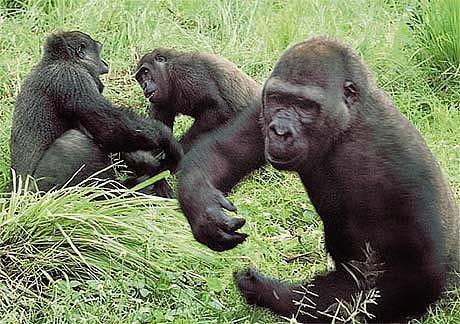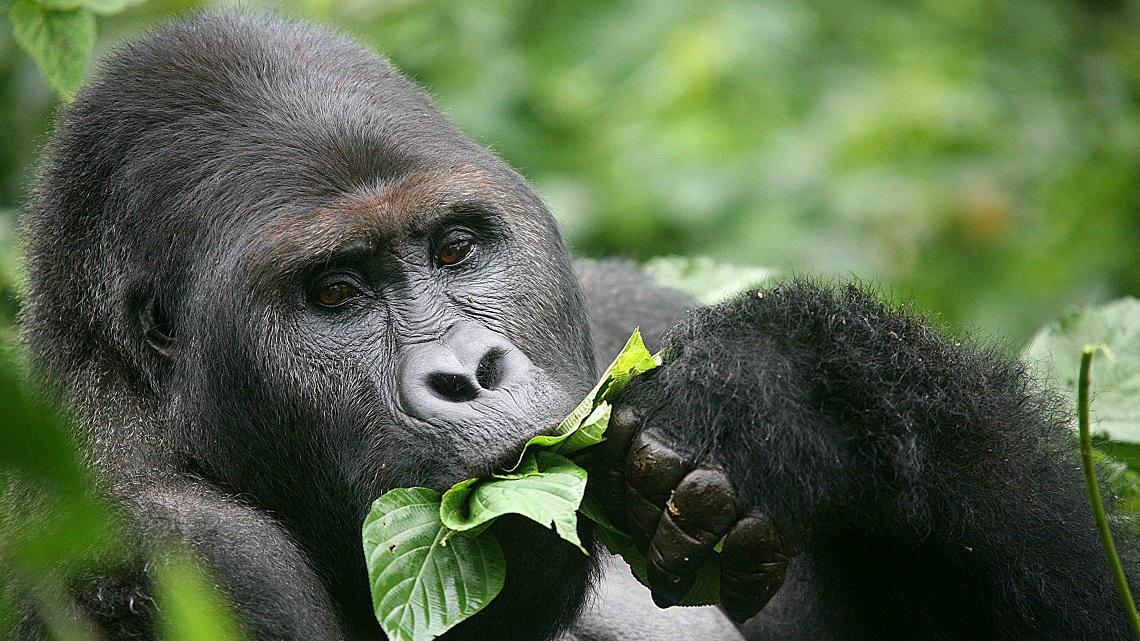The first image is the image on the left, the second image is the image on the right. Given the left and right images, does the statement "An image shows one gorilla munching on something." hold true? Answer yes or no. Yes. The first image is the image on the left, the second image is the image on the right. Assess this claim about the two images: "A gorilla is eating something in one of the images.". Correct or not? Answer yes or no. Yes. 